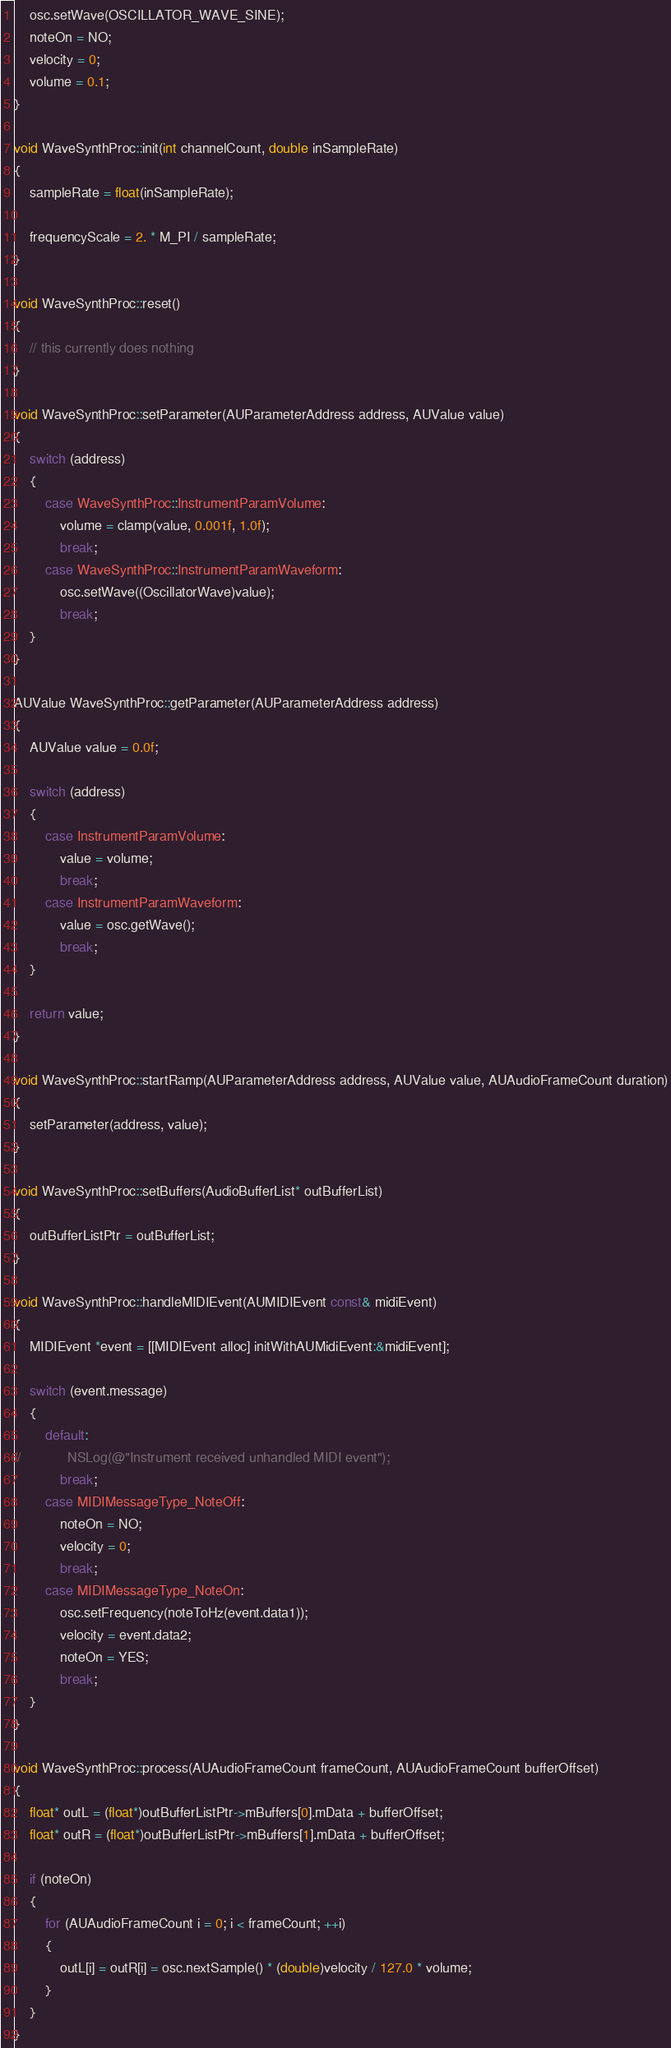Convert code to text. <code><loc_0><loc_0><loc_500><loc_500><_ObjectiveC_>    osc.setWave(OSCILLATOR_WAVE_SINE);
    noteOn = NO;
    velocity = 0;
    volume = 0.1;
}

void WaveSynthProc::init(int channelCount, double inSampleRate)
{
    sampleRate = float(inSampleRate);
    
    frequencyScale = 2. * M_PI / sampleRate;
}

void WaveSynthProc::reset()
{
    // this currently does nothing
}

void WaveSynthProc::setParameter(AUParameterAddress address, AUValue value)
{
    switch (address)
    {
        case WaveSynthProc::InstrumentParamVolume:
            volume = clamp(value, 0.001f, 1.0f);
            break;
        case WaveSynthProc::InstrumentParamWaveform:
            osc.setWave((OscillatorWave)value);
            break;
    }
}

AUValue WaveSynthProc::getParameter(AUParameterAddress address)
{
    AUValue value = 0.0f;
    
    switch (address)
    {
        case InstrumentParamVolume:
            value = volume;
            break;
        case InstrumentParamWaveform:
            value = osc.getWave();
            break;
    }
    
    return value;
}

void WaveSynthProc::startRamp(AUParameterAddress address, AUValue value, AUAudioFrameCount duration)
{
    setParameter(address, value);
}

void WaveSynthProc::setBuffers(AudioBufferList* outBufferList)
{
    outBufferListPtr = outBufferList;
}

void WaveSynthProc::handleMIDIEvent(AUMIDIEvent const& midiEvent)
{
    MIDIEvent *event = [[MIDIEvent alloc] initWithAUMidiEvent:&midiEvent];
    
    switch (event.message)
    {
        default:
//            NSLog(@"Instrument received unhandled MIDI event");
            break;
        case MIDIMessageType_NoteOff:
            noteOn = NO;
            velocity = 0;
            break;
        case MIDIMessageType_NoteOn:
            osc.setFrequency(noteToHz(event.data1));
            velocity = event.data2;
            noteOn = YES;
            break;
    }
}

void WaveSynthProc::process(AUAudioFrameCount frameCount, AUAudioFrameCount bufferOffset)
{
    float* outL = (float*)outBufferListPtr->mBuffers[0].mData + bufferOffset;
    float* outR = (float*)outBufferListPtr->mBuffers[1].mData + bufferOffset;
    
    if (noteOn)
    {
        for (AUAudioFrameCount i = 0; i < frameCount; ++i)
        {
            outL[i] = outR[i] = osc.nextSample() * (double)velocity / 127.0 * volume;
        }
    }
}
</code> 